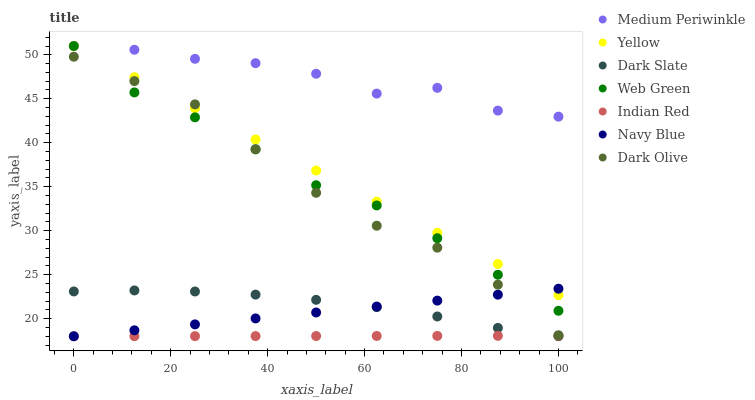Does Indian Red have the minimum area under the curve?
Answer yes or no. Yes. Does Medium Periwinkle have the maximum area under the curve?
Answer yes or no. Yes. Does Dark Olive have the minimum area under the curve?
Answer yes or no. No. Does Dark Olive have the maximum area under the curve?
Answer yes or no. No. Is Indian Red the smoothest?
Answer yes or no. Yes. Is Medium Periwinkle the roughest?
Answer yes or no. Yes. Is Dark Olive the smoothest?
Answer yes or no. No. Is Dark Olive the roughest?
Answer yes or no. No. Does Navy Blue have the lowest value?
Answer yes or no. Yes. Does Dark Olive have the lowest value?
Answer yes or no. No. Does Yellow have the highest value?
Answer yes or no. Yes. Does Dark Olive have the highest value?
Answer yes or no. No. Is Dark Slate less than Dark Olive?
Answer yes or no. Yes. Is Dark Olive greater than Indian Red?
Answer yes or no. Yes. Does Navy Blue intersect Dark Slate?
Answer yes or no. Yes. Is Navy Blue less than Dark Slate?
Answer yes or no. No. Is Navy Blue greater than Dark Slate?
Answer yes or no. No. Does Dark Slate intersect Dark Olive?
Answer yes or no. No. 